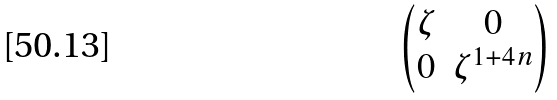Convert formula to latex. <formula><loc_0><loc_0><loc_500><loc_500>\begin{pmatrix} \zeta & 0 \\ 0 & \zeta ^ { 1 + 4 n } \end{pmatrix}</formula> 